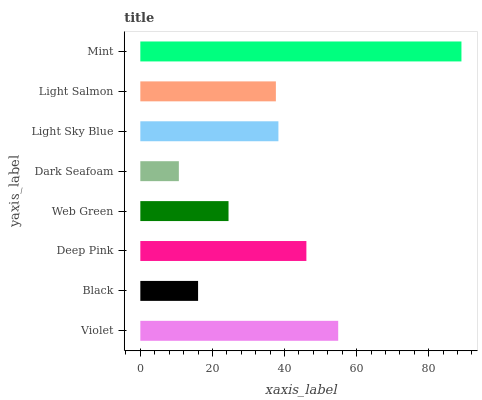Is Dark Seafoam the minimum?
Answer yes or no. Yes. Is Mint the maximum?
Answer yes or no. Yes. Is Black the minimum?
Answer yes or no. No. Is Black the maximum?
Answer yes or no. No. Is Violet greater than Black?
Answer yes or no. Yes. Is Black less than Violet?
Answer yes or no. Yes. Is Black greater than Violet?
Answer yes or no. No. Is Violet less than Black?
Answer yes or no. No. Is Light Sky Blue the high median?
Answer yes or no. Yes. Is Light Salmon the low median?
Answer yes or no. Yes. Is Black the high median?
Answer yes or no. No. Is Light Sky Blue the low median?
Answer yes or no. No. 